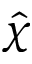Convert formula to latex. <formula><loc_0><loc_0><loc_500><loc_500>\hat { \chi }</formula> 